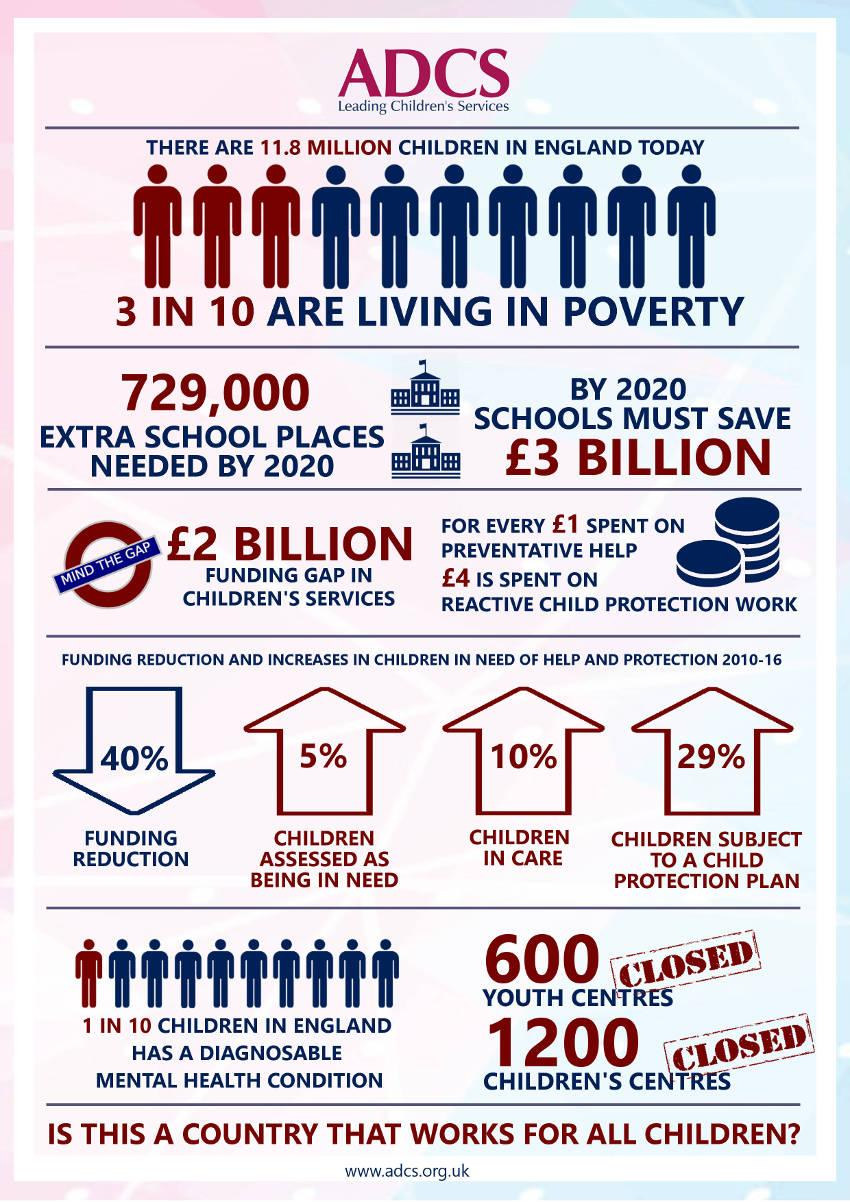Mention a couple of crucial points in this snapshot. According to official statistics, more than 1800 children's centers and youth centers have been shut down in the past few years. According to the data, only 5% of children are assessed as being in need. According to recent statistics, approximately 10% of children in England have a diagnosable mental health condition. According to the data, approximately 29% of children are currently subject to a child protection plan. In England, over 30% of children are living in poverty, which is a significant and concerning issue that requires attention and action from policymakers and society as a whole. 